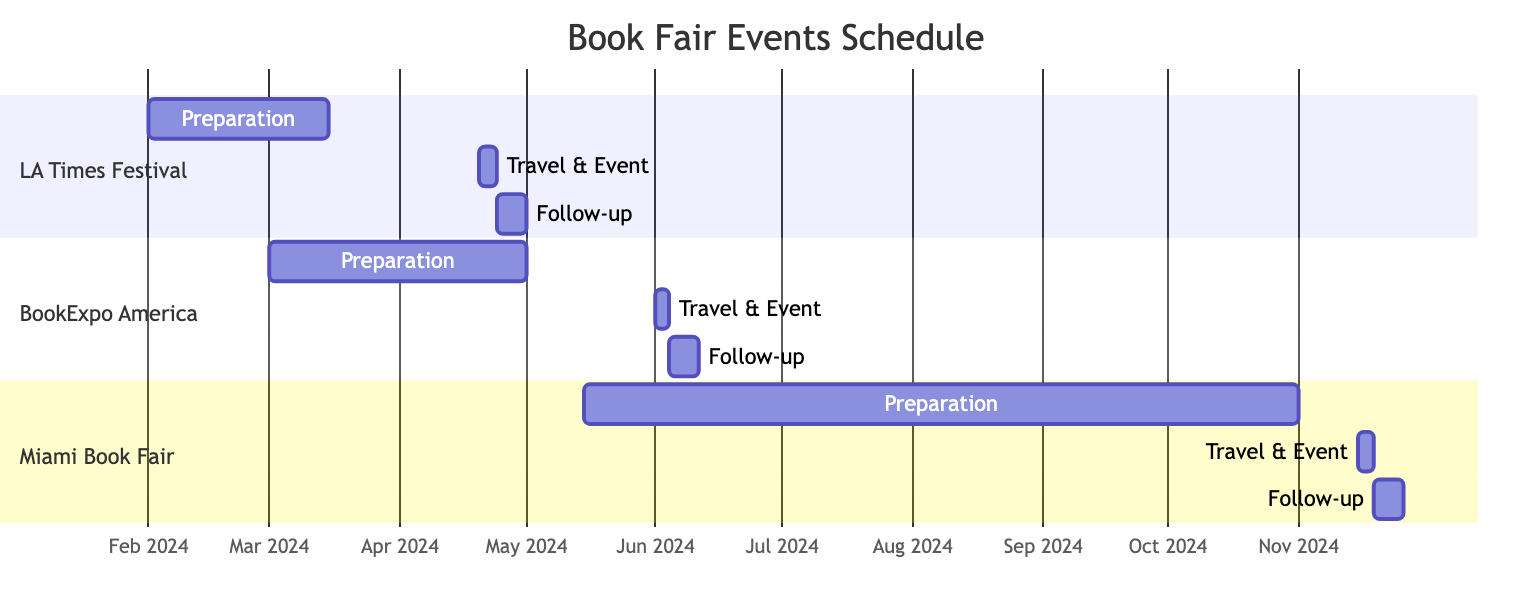What are the travel dates for the Los Angeles Times Festival of Books? The diagram indicates that the travel dates for the Los Angeles Times Festival of Books are from April 20, 2024, to April 23, 2024. This is clearly shown in the section dedicated to this event.
Answer: April 20 to April 23 How long is the preparation period for BookExpo America? In the Gantt chart for BookExpo America, the preparation period starts on March 1, 2024, and ends on May 1, 2024. The duration can be calculated by subtracting the start date from the end date, which equals 2 months.
Answer: 2 months What is the follow-up duration after the Miami Book Fair? The follow-up actions for the Miami Book Fair start on November 19, 2024, and last for 7 days, as indicated directly in that section of the chart.
Answer: 7 days Which event has the shortest preparation period? By examining the preparation periods in the Gantt chart, the Los Angeles Times Festival of Books has a preparation period from February 1, 2024, to March 15, 2024, totaling 1.5 months, which is shorter than the other events.
Answer: 1.5 months What is the last event listed in the diagram? The Gantt chart presents the events in a sequential order, and the last event listed is the Miami Book Fair, which is scheduled for its travel dates in November 2024.
Answer: Miami Book Fair How do the follow-up actions for BookExpo America compare in timing to those of the Los Angeles Times Festival of Books? The follow-up actions for BookExpo America start on June 4, 2024, while those for the Los Angeles Times Festival of Books begin on April 24, 2024. Comparing the two dates, the follow-up for BookExpo America starts 41 days after the follow-up for the Los Angeles Times Festival, indicating more time before following up after this event.
Answer: 41 days later What activities are planned as follow-up for the Miami Book Fair? The follow-up actions for the Miami Book Fair include gathering feedback from event sessions, updating book sales links, and engaging with attendees on book platforms, as shown in the relevant section of the Gantt chart.
Answer: Gather feedback, update book sales links, engage with attendees 